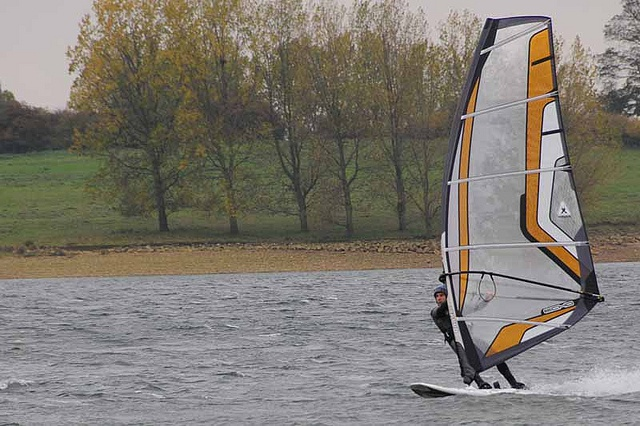Describe the objects in this image and their specific colors. I can see people in darkgray, black, gray, and brown tones and surfboard in darkgray, lightgray, black, and gray tones in this image. 